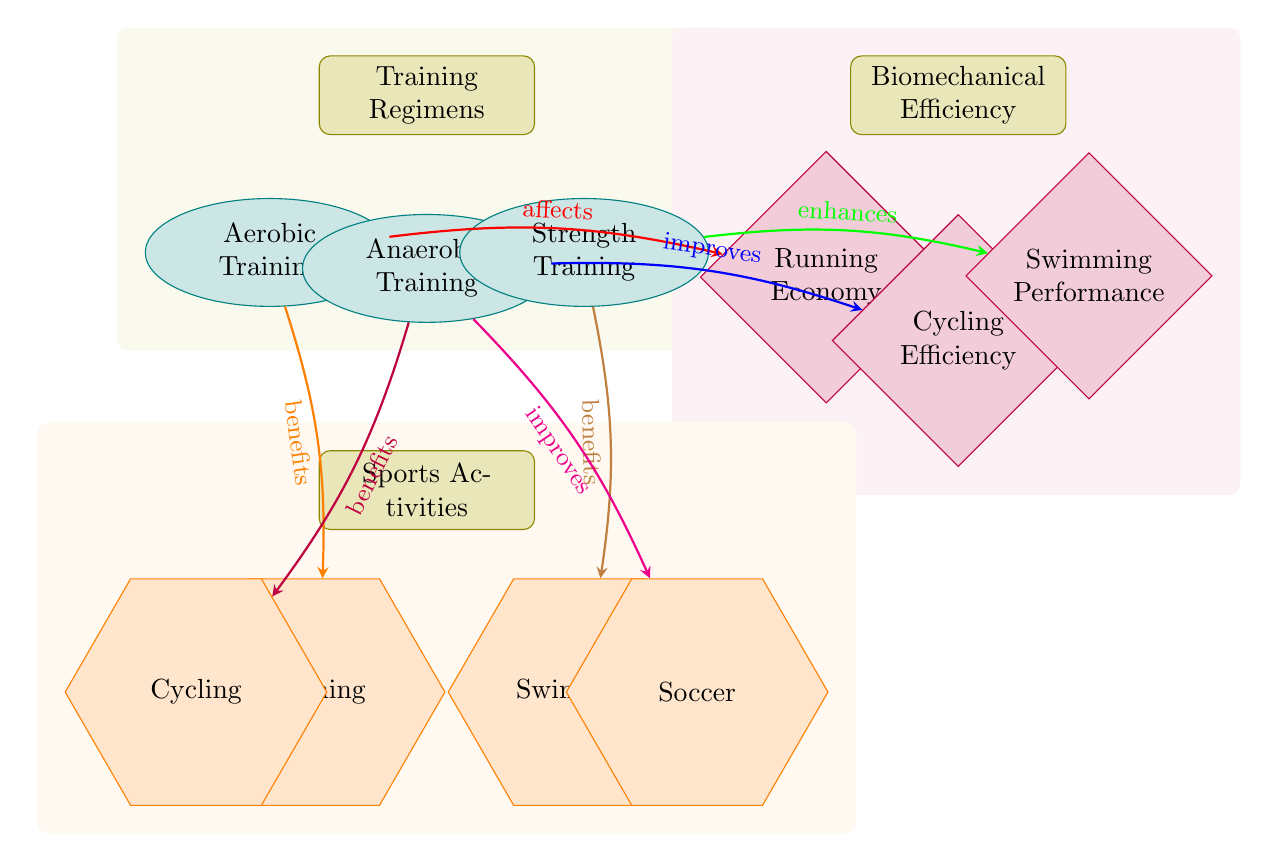What training regimen affects running economy? The diagram shows that aerobic training affects running economy, indicated by the red edge pointing from aerobic training to the running economy metric.
Answer: Aerobic Training How many sporting activities are depicted in the diagram? By counting the shapes labeled as activities at the bottom of the diagram, we find there are four: running, cycling, swimming, and soccer.
Answer: Four Which training regimen enhances swimming performance? The diagram indicates that strength training enhances swimming performance, as shown by the green edge connecting strength training to swimming performance.
Answer: Strength Training What is the relationship between anaerobic training and cycling efficiency? According to the diagram, anaerobic training improves cycling efficiency, described by the blue edge leading from anaerobic training to cycling efficiency.
Answer: Improves Which sport benefits from aerobic training? The diagram shows that running benefits from aerobic training, indicated by the orange edge linking aerobic training to the running activity.
Answer: Running What is the unique metric associated with running? The only metric specifically associated with running in the diagram is running economy, found positioned directly beneath biomechanical efficiency.
Answer: Running Economy How many edges are there leading from training regimens to sports activities? By assessing the diagram, we observe that there are three distinct edges leading from training regimens (aerobic, anaerobic, and strength) to sports activities (running, cycling, swimming, and soccer).
Answer: Three What effect does anaerobic training have on soccer? The relationship indicated by the magenta edge states that anaerobic training improves soccer performance, marking a direct influence from anaerobic training toward the activity of soccer.
Answer: Improves Which training regimen benefits cycling specifically? The diagram points to anaerobic training as it relates directly to cycling, with the purple edge indicating this benefit.
Answer: Anaerobic Training 